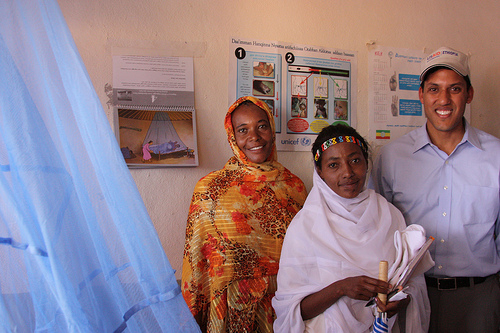<image>
Can you confirm if the man is to the left of the woman? Yes. From this viewpoint, the man is positioned to the left side relative to the woman. 